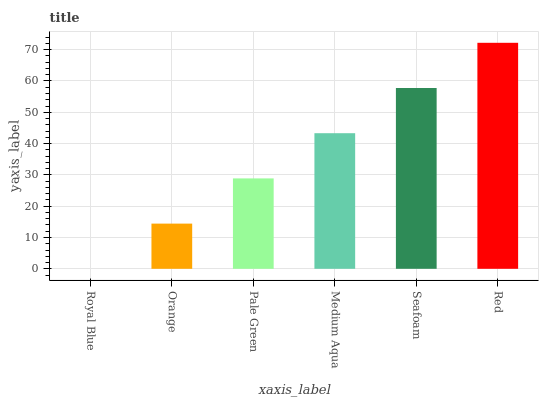Is Orange the minimum?
Answer yes or no. No. Is Orange the maximum?
Answer yes or no. No. Is Orange greater than Royal Blue?
Answer yes or no. Yes. Is Royal Blue less than Orange?
Answer yes or no. Yes. Is Royal Blue greater than Orange?
Answer yes or no. No. Is Orange less than Royal Blue?
Answer yes or no. No. Is Medium Aqua the high median?
Answer yes or no. Yes. Is Pale Green the low median?
Answer yes or no. Yes. Is Royal Blue the high median?
Answer yes or no. No. Is Orange the low median?
Answer yes or no. No. 